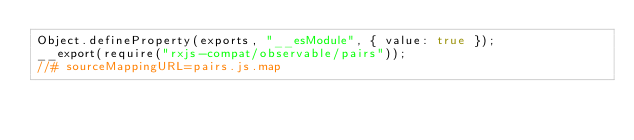Convert code to text. <code><loc_0><loc_0><loc_500><loc_500><_JavaScript_>Object.defineProperty(exports, "__esModule", { value: true });
__export(require("rxjs-compat/observable/pairs"));
//# sourceMappingURL=pairs.js.map</code> 